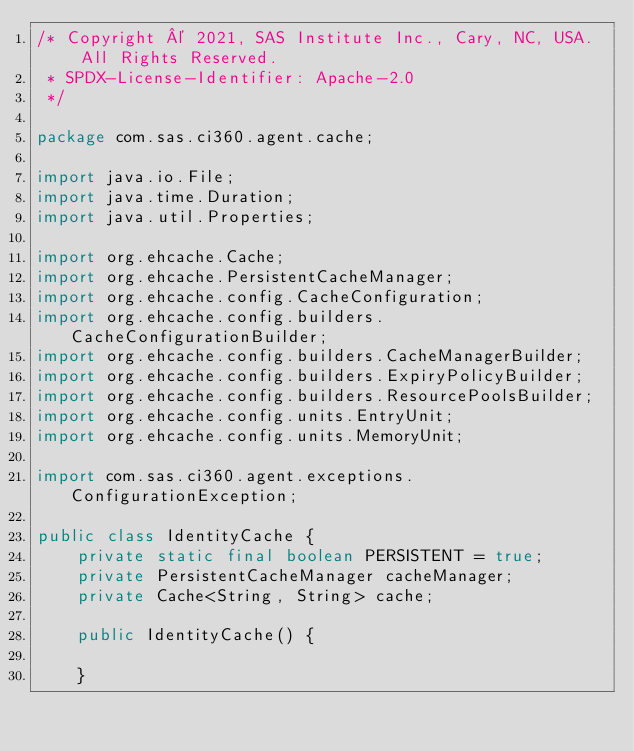<code> <loc_0><loc_0><loc_500><loc_500><_Java_>/* Copyright © 2021, SAS Institute Inc., Cary, NC, USA.  All Rights Reserved.
 * SPDX-License-Identifier: Apache-2.0
 */

package com.sas.ci360.agent.cache;

import java.io.File;
import java.time.Duration;
import java.util.Properties;

import org.ehcache.Cache;
import org.ehcache.PersistentCacheManager;
import org.ehcache.config.CacheConfiguration;
import org.ehcache.config.builders.CacheConfigurationBuilder;
import org.ehcache.config.builders.CacheManagerBuilder;
import org.ehcache.config.builders.ExpiryPolicyBuilder;
import org.ehcache.config.builders.ResourcePoolsBuilder;
import org.ehcache.config.units.EntryUnit;
import org.ehcache.config.units.MemoryUnit;

import com.sas.ci360.agent.exceptions.ConfigurationException;

public class IdentityCache {
	private static final boolean PERSISTENT = true;
	private PersistentCacheManager cacheManager;
	private Cache<String, String> cache;
	
	public IdentityCache() {

	}
	</code> 